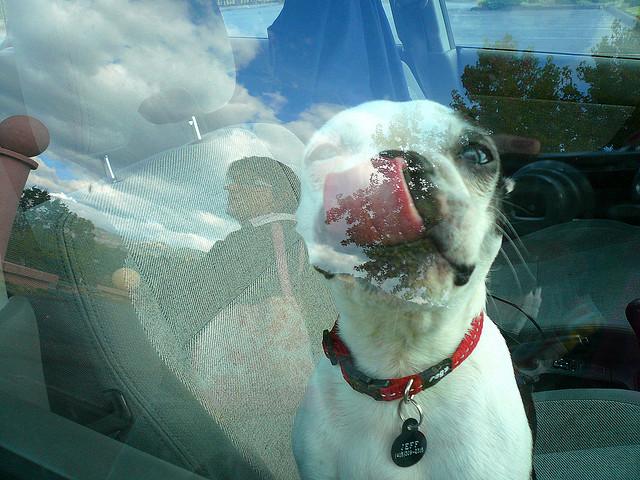What does the tag on the dog's collar say?
Be succinct. Jeff. What is the dog doing?
Keep it brief. Licking window. Is the person on the window a male or female?
Short answer required. Male. 